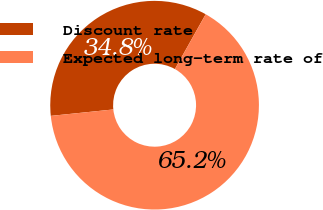Convert chart to OTSL. <chart><loc_0><loc_0><loc_500><loc_500><pie_chart><fcel>Discount rate<fcel>Expected long-term rate of<nl><fcel>34.78%<fcel>65.22%<nl></chart> 